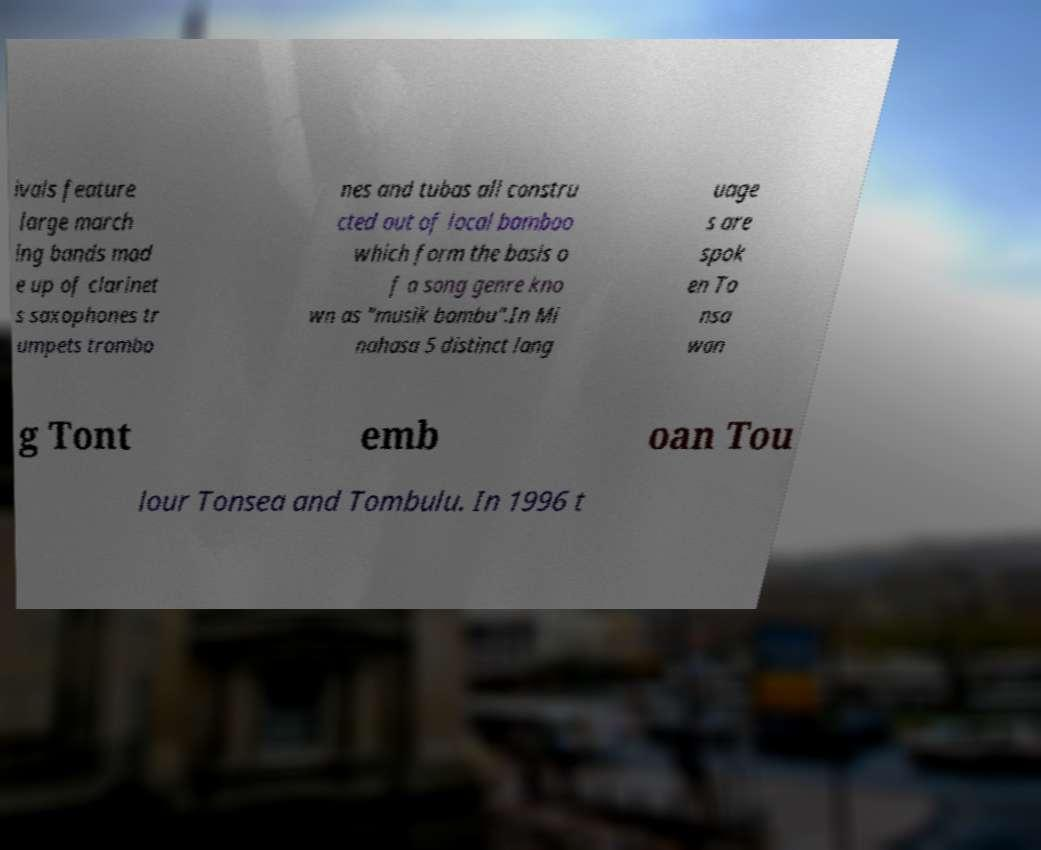Can you accurately transcribe the text from the provided image for me? ivals feature large march ing bands mad e up of clarinet s saxophones tr umpets trombo nes and tubas all constru cted out of local bamboo which form the basis o f a song genre kno wn as "musik bambu".In Mi nahasa 5 distinct lang uage s are spok en To nsa wan g Tont emb oan Tou lour Tonsea and Tombulu. In 1996 t 